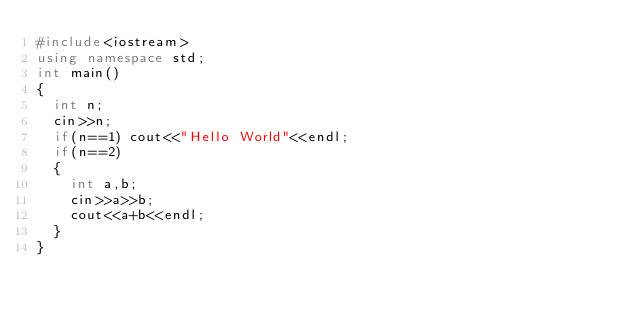<code> <loc_0><loc_0><loc_500><loc_500><_C++_>#include<iostream>
using namespace std;
int main()
{
  int n;
  cin>>n;
  if(n==1) cout<<"Hello World"<<endl;
  if(n==2)
  {
    int a,b;
    cin>>a>>b;
    cout<<a+b<<endl;
  }
}</code> 